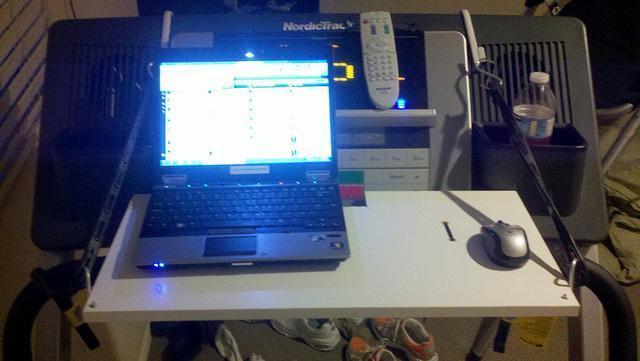How many dining tables are in the picture?
Give a very brief answer. 1. How many laptops are there?
Give a very brief answer. 1. How many bottles are there?
Give a very brief answer. 1. How many sheep are there?
Give a very brief answer. 0. 